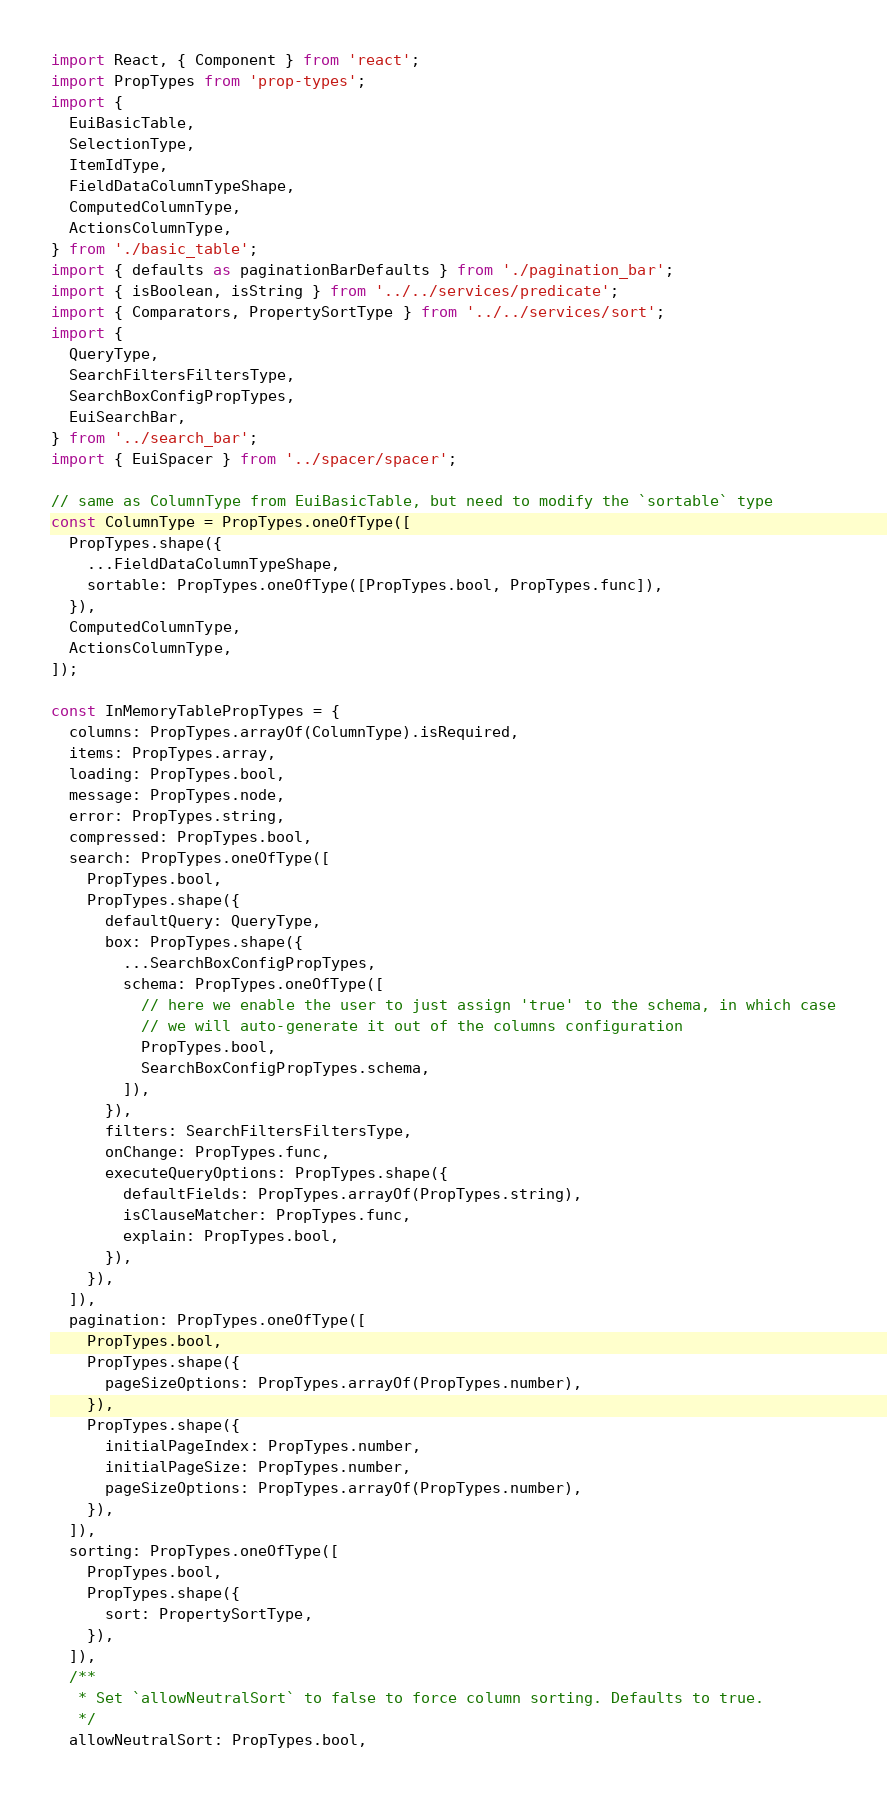<code> <loc_0><loc_0><loc_500><loc_500><_JavaScript_>import React, { Component } from 'react';
import PropTypes from 'prop-types';
import {
  EuiBasicTable,
  SelectionType,
  ItemIdType,
  FieldDataColumnTypeShape,
  ComputedColumnType,
  ActionsColumnType,
} from './basic_table';
import { defaults as paginationBarDefaults } from './pagination_bar';
import { isBoolean, isString } from '../../services/predicate';
import { Comparators, PropertySortType } from '../../services/sort';
import {
  QueryType,
  SearchFiltersFiltersType,
  SearchBoxConfigPropTypes,
  EuiSearchBar,
} from '../search_bar';
import { EuiSpacer } from '../spacer/spacer';

// same as ColumnType from EuiBasicTable, but need to modify the `sortable` type
const ColumnType = PropTypes.oneOfType([
  PropTypes.shape({
    ...FieldDataColumnTypeShape,
    sortable: PropTypes.oneOfType([PropTypes.bool, PropTypes.func]),
  }),
  ComputedColumnType,
  ActionsColumnType,
]);

const InMemoryTablePropTypes = {
  columns: PropTypes.arrayOf(ColumnType).isRequired,
  items: PropTypes.array,
  loading: PropTypes.bool,
  message: PropTypes.node,
  error: PropTypes.string,
  compressed: PropTypes.bool,
  search: PropTypes.oneOfType([
    PropTypes.bool,
    PropTypes.shape({
      defaultQuery: QueryType,
      box: PropTypes.shape({
        ...SearchBoxConfigPropTypes,
        schema: PropTypes.oneOfType([
          // here we enable the user to just assign 'true' to the schema, in which case
          // we will auto-generate it out of the columns configuration
          PropTypes.bool,
          SearchBoxConfigPropTypes.schema,
        ]),
      }),
      filters: SearchFiltersFiltersType,
      onChange: PropTypes.func,
      executeQueryOptions: PropTypes.shape({
        defaultFields: PropTypes.arrayOf(PropTypes.string),
        isClauseMatcher: PropTypes.func,
        explain: PropTypes.bool,
      }),
    }),
  ]),
  pagination: PropTypes.oneOfType([
    PropTypes.bool,
    PropTypes.shape({
      pageSizeOptions: PropTypes.arrayOf(PropTypes.number),
    }),
    PropTypes.shape({
      initialPageIndex: PropTypes.number,
      initialPageSize: PropTypes.number,
      pageSizeOptions: PropTypes.arrayOf(PropTypes.number),
    }),
  ]),
  sorting: PropTypes.oneOfType([
    PropTypes.bool,
    PropTypes.shape({
      sort: PropertySortType,
    }),
  ]),
  /**
   * Set `allowNeutralSort` to false to force column sorting. Defaults to true.
   */
  allowNeutralSort: PropTypes.bool,</code> 